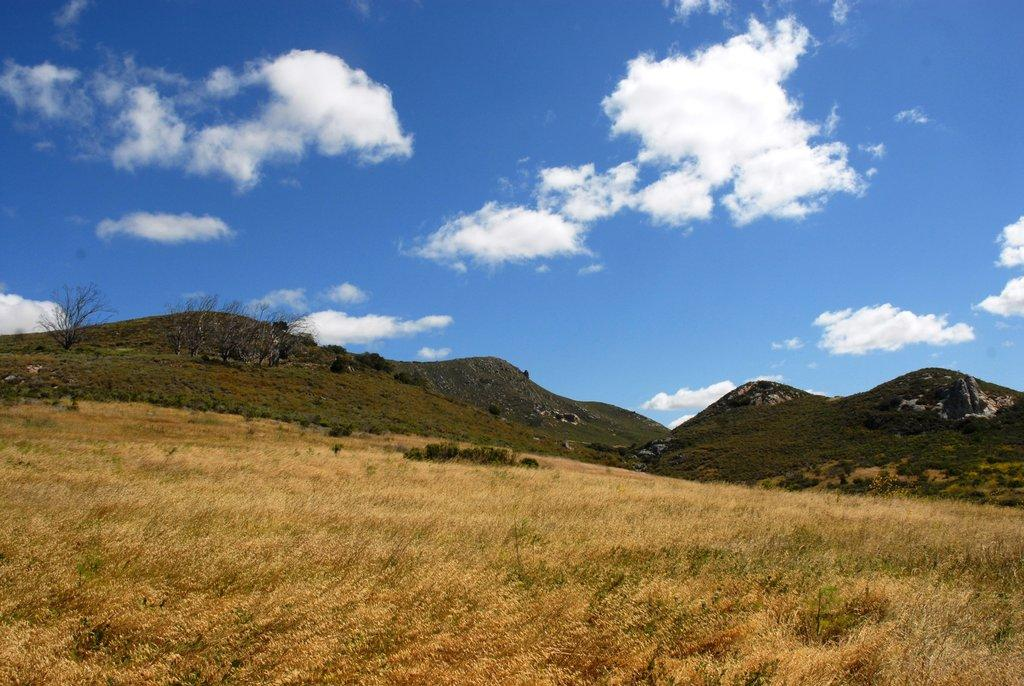What type of vegetation is at the bottom of the image? There is grass at the bottom of the image. What geographical features are in the middle of the image? There are hills in the middle of the image. What is visible at the top of the image? The sky is visible at the top of the image. Reasoning: Let'ing: Let's think step by step in order to produce the conversation. We start by identifying the main subjects and objects in the image based on the provided facts. We then formulate questions that focus on the location and characteristics of these subjects and objects, ensuring that each question can be answered definitively with the information given. We avoid yes/no questions and ensure that the language is simple and clear. Absurd Question/Answer: What type of instrument is the carpenter playing on the hill in the image? There is no carpenter or instrument present in the image; it features grass, hills, and the sky. How does the carpenter pull the instrument in the image? There is no carpenter or instrument present in the image, so it is not possible to answer that question. What type of instrument is the carpenter playing on the hill in the image? There is no carpenter or instrument present in the image; it features grass, hills, and the sky. How does the carpenter pull the instrument in the image? There is no carpenter or instrument present in the image, so it is not possible to answer that question. 